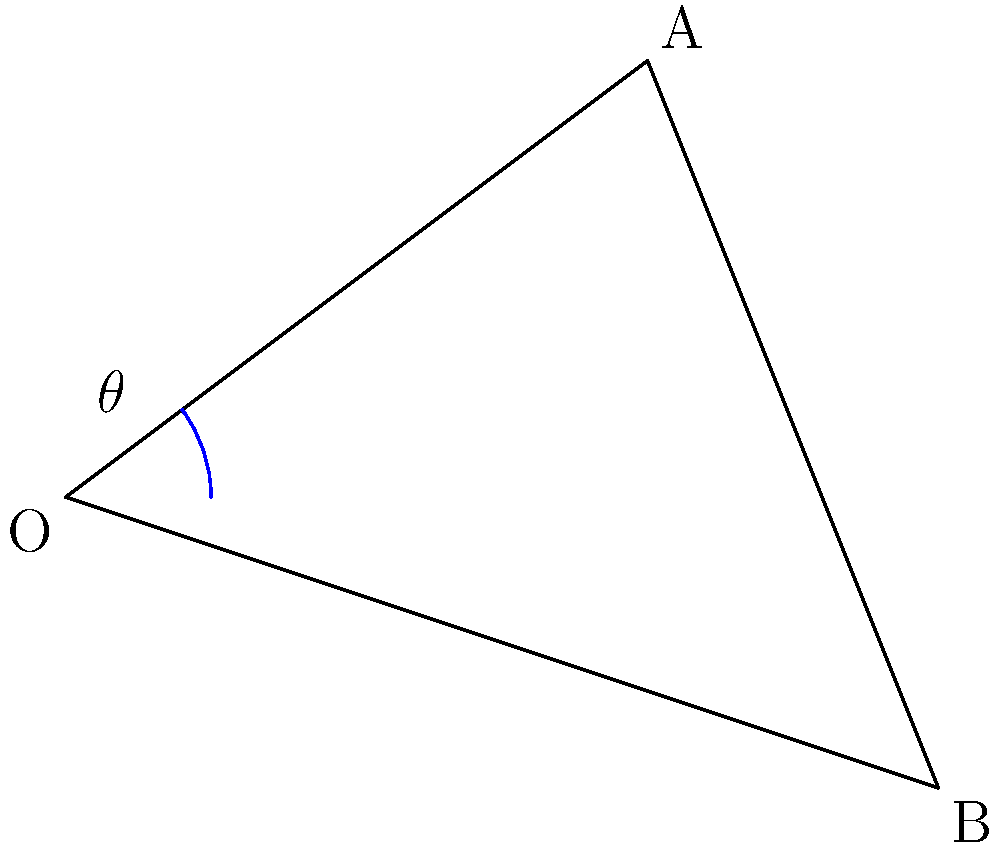During a crucial play, two players start skating from the same point O. Player A skates towards point A (4,3), while player B skates towards point B (6,-2). What is the angle $\theta$ between their skating paths? To find the angle between the two skating paths, we need to follow these steps:

1. Identify the vectors representing each player's path:
   $\vec{OA} = (4,3)$ and $\vec{OB} = (6,-2)$

2. Calculate the dot product of these vectors:
   $\vec{OA} \cdot \vec{OB} = 4(6) + 3(-2) = 24 - 6 = 18$

3. Calculate the magnitudes of both vectors:
   $|\vec{OA}| = \sqrt{4^2 + 3^2} = \sqrt{25} = 5$
   $|\vec{OB}| = \sqrt{6^2 + (-2)^2} = \sqrt{40} = 2\sqrt{10}$

4. Use the dot product formula to find $\cos\theta$:
   $\cos\theta = \frac{\vec{OA} \cdot \vec{OB}}{|\vec{OA}||\vec{OB}|} = \frac{18}{5(2\sqrt{10})} = \frac{9}{5\sqrt{10}}$

5. Take the inverse cosine (arccos) to find $\theta$:
   $\theta = \arccos(\frac{9}{5\sqrt{10}}) \approx 53.13°$

Therefore, the angle between the two players' skating paths is approximately 53.13°.
Answer: $53.13°$ 